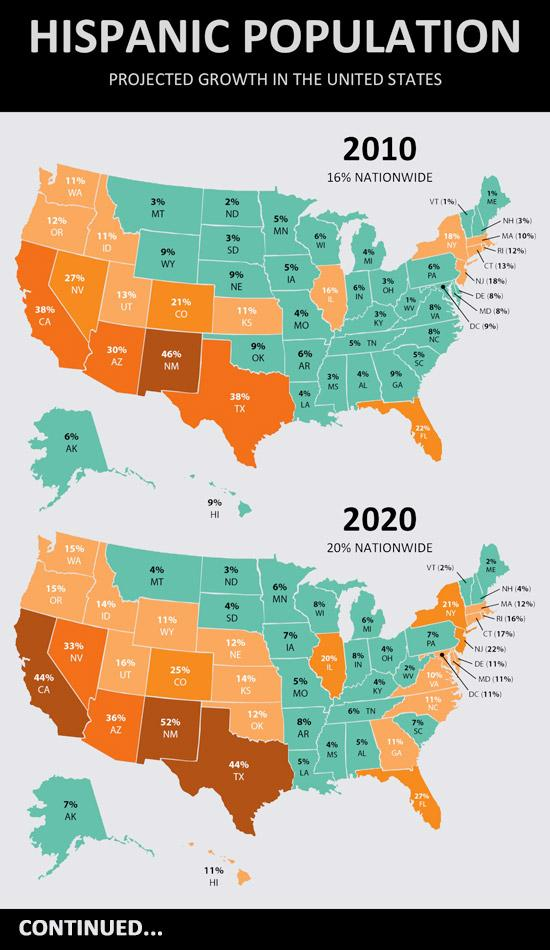Identify some key points in this picture. The Hispanic population of Montana in 2020 was 1% higher than in 2010. The Hispanic population of North Dakota in 2020 was found to be 1% higher than in 2010. The Hispanic population in Texas in 2020 was 8.5 million, an increase of 6% from the 8.0 million in 2010. The Hispanic population of Missouri in 2020 was found to have increased by 1% compared to the 2010 census data. The Hispanic population of the Northeast region in the United States has increased by 3% from 2020 to 2010. 